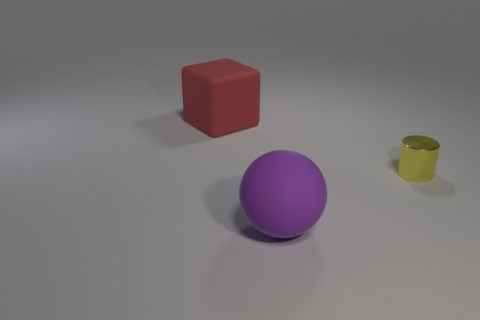Is there any other thing that is the same material as the tiny yellow cylinder?
Ensure brevity in your answer.  No. How many shiny objects are either yellow cylinders or red objects?
Ensure brevity in your answer.  1. There is a thing that is both behind the large purple matte thing and on the left side of the metal cylinder; what material is it?
Offer a very short reply. Rubber. Are there any small cylinders on the left side of the rubber thing in front of the red matte block to the left of the tiny shiny thing?
Provide a short and direct response. No. What is the shape of the purple thing that is the same material as the cube?
Offer a very short reply. Sphere. Are there fewer objects on the right side of the red thing than things that are behind the small metallic object?
Provide a short and direct response. No. How many tiny things are either green matte cubes or red blocks?
Offer a terse response. 0. There is a large thing on the right side of the large rubber block; is it the same shape as the large object behind the yellow metal object?
Provide a short and direct response. No. What size is the rubber object behind the matte object that is on the right side of the big object that is to the left of the purple rubber thing?
Your response must be concise. Large. There is a rubber thing behind the yellow metal cylinder; what is its size?
Offer a terse response. Large. 